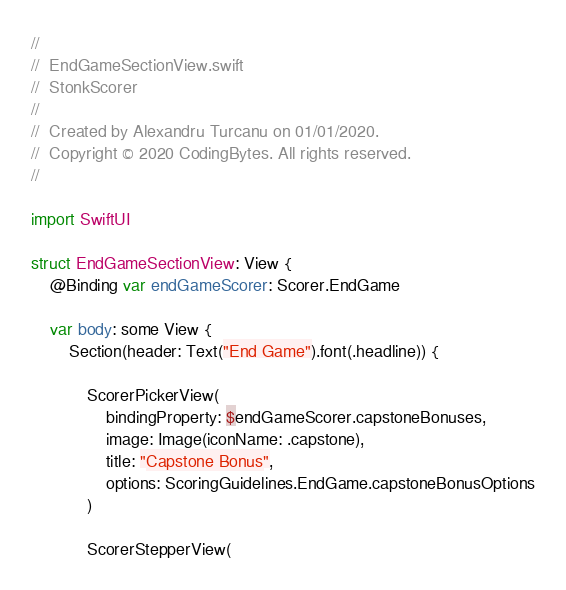<code> <loc_0><loc_0><loc_500><loc_500><_Swift_>//
//  EndGameSectionView.swift
//  StonkScorer
//
//  Created by Alexandru Turcanu on 01/01/2020.
//  Copyright © 2020 CodingBytes. All rights reserved.
//

import SwiftUI

struct EndGameSectionView: View {
    @Binding var endGameScorer: Scorer.EndGame

    var body: some View {
        Section(header: Text("End Game").font(.headline)) {

            ScorerPickerView(
                bindingProperty: $endGameScorer.capstoneBonuses,
                image: Image(iconName: .capstone),
                title: "Capstone Bonus",
                options: ScoringGuidelines.EndGame.capstoneBonusOptions
            )

            ScorerStepperView(</code> 